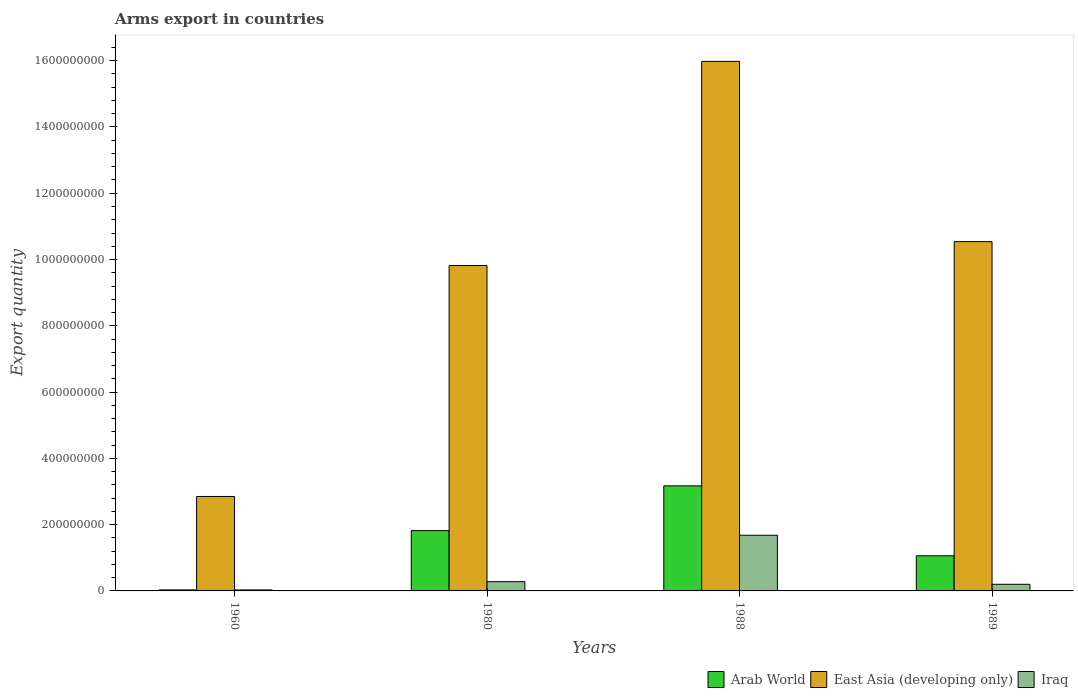How many different coloured bars are there?
Provide a succinct answer. 3. How many groups of bars are there?
Your response must be concise. 4. Are the number of bars per tick equal to the number of legend labels?
Your response must be concise. Yes. Are the number of bars on each tick of the X-axis equal?
Your answer should be very brief. Yes. How many bars are there on the 3rd tick from the left?
Give a very brief answer. 3. What is the label of the 1st group of bars from the left?
Offer a very short reply. 1960. In how many cases, is the number of bars for a given year not equal to the number of legend labels?
Ensure brevity in your answer.  0. What is the total arms export in Iraq in 1980?
Offer a terse response. 2.80e+07. Across all years, what is the maximum total arms export in Iraq?
Make the answer very short. 1.68e+08. In which year was the total arms export in East Asia (developing only) maximum?
Provide a succinct answer. 1988. What is the total total arms export in East Asia (developing only) in the graph?
Offer a very short reply. 3.92e+09. What is the difference between the total arms export in Iraq in 1960 and that in 1980?
Make the answer very short. -2.50e+07. What is the difference between the total arms export in Iraq in 1989 and the total arms export in East Asia (developing only) in 1980?
Offer a very short reply. -9.62e+08. What is the average total arms export in Arab World per year?
Your response must be concise. 1.52e+08. In the year 1988, what is the difference between the total arms export in East Asia (developing only) and total arms export in Arab World?
Your answer should be very brief. 1.28e+09. What is the ratio of the total arms export in Iraq in 1960 to that in 1988?
Your answer should be compact. 0.02. Is the total arms export in Arab World in 1988 less than that in 1989?
Make the answer very short. No. What is the difference between the highest and the second highest total arms export in East Asia (developing only)?
Provide a succinct answer. 5.44e+08. What is the difference between the highest and the lowest total arms export in Iraq?
Provide a short and direct response. 1.65e+08. In how many years, is the total arms export in East Asia (developing only) greater than the average total arms export in East Asia (developing only) taken over all years?
Offer a very short reply. 3. What does the 2nd bar from the left in 1980 represents?
Your answer should be very brief. East Asia (developing only). What does the 3rd bar from the right in 1988 represents?
Offer a very short reply. Arab World. Is it the case that in every year, the sum of the total arms export in Iraq and total arms export in Arab World is greater than the total arms export in East Asia (developing only)?
Provide a succinct answer. No. Are all the bars in the graph horizontal?
Your response must be concise. No. What is the difference between two consecutive major ticks on the Y-axis?
Your answer should be very brief. 2.00e+08. Does the graph contain any zero values?
Keep it short and to the point. No. Does the graph contain grids?
Provide a succinct answer. No. How many legend labels are there?
Your answer should be compact. 3. How are the legend labels stacked?
Your response must be concise. Horizontal. What is the title of the graph?
Ensure brevity in your answer.  Arms export in countries. Does "Colombia" appear as one of the legend labels in the graph?
Your answer should be compact. No. What is the label or title of the Y-axis?
Ensure brevity in your answer.  Export quantity. What is the Export quantity of East Asia (developing only) in 1960?
Provide a succinct answer. 2.85e+08. What is the Export quantity of Iraq in 1960?
Give a very brief answer. 3.00e+06. What is the Export quantity in Arab World in 1980?
Offer a terse response. 1.82e+08. What is the Export quantity of East Asia (developing only) in 1980?
Your answer should be very brief. 9.82e+08. What is the Export quantity in Iraq in 1980?
Ensure brevity in your answer.  2.80e+07. What is the Export quantity in Arab World in 1988?
Give a very brief answer. 3.17e+08. What is the Export quantity of East Asia (developing only) in 1988?
Offer a very short reply. 1.60e+09. What is the Export quantity in Iraq in 1988?
Your answer should be very brief. 1.68e+08. What is the Export quantity in Arab World in 1989?
Ensure brevity in your answer.  1.06e+08. What is the Export quantity of East Asia (developing only) in 1989?
Keep it short and to the point. 1.05e+09. What is the Export quantity of Iraq in 1989?
Your answer should be very brief. 2.00e+07. Across all years, what is the maximum Export quantity in Arab World?
Your answer should be compact. 3.17e+08. Across all years, what is the maximum Export quantity in East Asia (developing only)?
Ensure brevity in your answer.  1.60e+09. Across all years, what is the maximum Export quantity in Iraq?
Ensure brevity in your answer.  1.68e+08. Across all years, what is the minimum Export quantity of Arab World?
Ensure brevity in your answer.  3.00e+06. Across all years, what is the minimum Export quantity in East Asia (developing only)?
Give a very brief answer. 2.85e+08. What is the total Export quantity of Arab World in the graph?
Your answer should be compact. 6.08e+08. What is the total Export quantity of East Asia (developing only) in the graph?
Provide a short and direct response. 3.92e+09. What is the total Export quantity of Iraq in the graph?
Ensure brevity in your answer.  2.19e+08. What is the difference between the Export quantity of Arab World in 1960 and that in 1980?
Offer a very short reply. -1.79e+08. What is the difference between the Export quantity in East Asia (developing only) in 1960 and that in 1980?
Your answer should be very brief. -6.97e+08. What is the difference between the Export quantity of Iraq in 1960 and that in 1980?
Keep it short and to the point. -2.50e+07. What is the difference between the Export quantity in Arab World in 1960 and that in 1988?
Provide a short and direct response. -3.14e+08. What is the difference between the Export quantity of East Asia (developing only) in 1960 and that in 1988?
Offer a very short reply. -1.31e+09. What is the difference between the Export quantity in Iraq in 1960 and that in 1988?
Give a very brief answer. -1.65e+08. What is the difference between the Export quantity of Arab World in 1960 and that in 1989?
Your response must be concise. -1.03e+08. What is the difference between the Export quantity in East Asia (developing only) in 1960 and that in 1989?
Offer a very short reply. -7.69e+08. What is the difference between the Export quantity of Iraq in 1960 and that in 1989?
Make the answer very short. -1.70e+07. What is the difference between the Export quantity of Arab World in 1980 and that in 1988?
Give a very brief answer. -1.35e+08. What is the difference between the Export quantity of East Asia (developing only) in 1980 and that in 1988?
Offer a very short reply. -6.16e+08. What is the difference between the Export quantity in Iraq in 1980 and that in 1988?
Your answer should be very brief. -1.40e+08. What is the difference between the Export quantity of Arab World in 1980 and that in 1989?
Offer a terse response. 7.60e+07. What is the difference between the Export quantity of East Asia (developing only) in 1980 and that in 1989?
Offer a terse response. -7.20e+07. What is the difference between the Export quantity in Iraq in 1980 and that in 1989?
Ensure brevity in your answer.  8.00e+06. What is the difference between the Export quantity in Arab World in 1988 and that in 1989?
Keep it short and to the point. 2.11e+08. What is the difference between the Export quantity in East Asia (developing only) in 1988 and that in 1989?
Your response must be concise. 5.44e+08. What is the difference between the Export quantity of Iraq in 1988 and that in 1989?
Offer a very short reply. 1.48e+08. What is the difference between the Export quantity of Arab World in 1960 and the Export quantity of East Asia (developing only) in 1980?
Offer a very short reply. -9.79e+08. What is the difference between the Export quantity of Arab World in 1960 and the Export quantity of Iraq in 1980?
Your answer should be very brief. -2.50e+07. What is the difference between the Export quantity of East Asia (developing only) in 1960 and the Export quantity of Iraq in 1980?
Your answer should be very brief. 2.57e+08. What is the difference between the Export quantity in Arab World in 1960 and the Export quantity in East Asia (developing only) in 1988?
Your answer should be very brief. -1.60e+09. What is the difference between the Export quantity of Arab World in 1960 and the Export quantity of Iraq in 1988?
Keep it short and to the point. -1.65e+08. What is the difference between the Export quantity of East Asia (developing only) in 1960 and the Export quantity of Iraq in 1988?
Your response must be concise. 1.17e+08. What is the difference between the Export quantity of Arab World in 1960 and the Export quantity of East Asia (developing only) in 1989?
Offer a terse response. -1.05e+09. What is the difference between the Export quantity in Arab World in 1960 and the Export quantity in Iraq in 1989?
Keep it short and to the point. -1.70e+07. What is the difference between the Export quantity of East Asia (developing only) in 1960 and the Export quantity of Iraq in 1989?
Ensure brevity in your answer.  2.65e+08. What is the difference between the Export quantity in Arab World in 1980 and the Export quantity in East Asia (developing only) in 1988?
Your answer should be compact. -1.42e+09. What is the difference between the Export quantity in Arab World in 1980 and the Export quantity in Iraq in 1988?
Offer a terse response. 1.40e+07. What is the difference between the Export quantity of East Asia (developing only) in 1980 and the Export quantity of Iraq in 1988?
Ensure brevity in your answer.  8.14e+08. What is the difference between the Export quantity of Arab World in 1980 and the Export quantity of East Asia (developing only) in 1989?
Provide a succinct answer. -8.72e+08. What is the difference between the Export quantity of Arab World in 1980 and the Export quantity of Iraq in 1989?
Your response must be concise. 1.62e+08. What is the difference between the Export quantity in East Asia (developing only) in 1980 and the Export quantity in Iraq in 1989?
Your response must be concise. 9.62e+08. What is the difference between the Export quantity in Arab World in 1988 and the Export quantity in East Asia (developing only) in 1989?
Your answer should be very brief. -7.37e+08. What is the difference between the Export quantity of Arab World in 1988 and the Export quantity of Iraq in 1989?
Make the answer very short. 2.97e+08. What is the difference between the Export quantity in East Asia (developing only) in 1988 and the Export quantity in Iraq in 1989?
Your answer should be very brief. 1.58e+09. What is the average Export quantity of Arab World per year?
Keep it short and to the point. 1.52e+08. What is the average Export quantity of East Asia (developing only) per year?
Your response must be concise. 9.80e+08. What is the average Export quantity of Iraq per year?
Offer a terse response. 5.48e+07. In the year 1960, what is the difference between the Export quantity in Arab World and Export quantity in East Asia (developing only)?
Your answer should be very brief. -2.82e+08. In the year 1960, what is the difference between the Export quantity in Arab World and Export quantity in Iraq?
Your response must be concise. 0. In the year 1960, what is the difference between the Export quantity in East Asia (developing only) and Export quantity in Iraq?
Your answer should be very brief. 2.82e+08. In the year 1980, what is the difference between the Export quantity in Arab World and Export quantity in East Asia (developing only)?
Keep it short and to the point. -8.00e+08. In the year 1980, what is the difference between the Export quantity of Arab World and Export quantity of Iraq?
Make the answer very short. 1.54e+08. In the year 1980, what is the difference between the Export quantity in East Asia (developing only) and Export quantity in Iraq?
Give a very brief answer. 9.54e+08. In the year 1988, what is the difference between the Export quantity of Arab World and Export quantity of East Asia (developing only)?
Your answer should be compact. -1.28e+09. In the year 1988, what is the difference between the Export quantity in Arab World and Export quantity in Iraq?
Keep it short and to the point. 1.49e+08. In the year 1988, what is the difference between the Export quantity of East Asia (developing only) and Export quantity of Iraq?
Provide a succinct answer. 1.43e+09. In the year 1989, what is the difference between the Export quantity of Arab World and Export quantity of East Asia (developing only)?
Offer a very short reply. -9.48e+08. In the year 1989, what is the difference between the Export quantity in Arab World and Export quantity in Iraq?
Provide a succinct answer. 8.60e+07. In the year 1989, what is the difference between the Export quantity in East Asia (developing only) and Export quantity in Iraq?
Your answer should be very brief. 1.03e+09. What is the ratio of the Export quantity of Arab World in 1960 to that in 1980?
Give a very brief answer. 0.02. What is the ratio of the Export quantity in East Asia (developing only) in 1960 to that in 1980?
Your response must be concise. 0.29. What is the ratio of the Export quantity of Iraq in 1960 to that in 1980?
Make the answer very short. 0.11. What is the ratio of the Export quantity of Arab World in 1960 to that in 1988?
Your answer should be compact. 0.01. What is the ratio of the Export quantity in East Asia (developing only) in 1960 to that in 1988?
Offer a very short reply. 0.18. What is the ratio of the Export quantity in Iraq in 1960 to that in 1988?
Offer a terse response. 0.02. What is the ratio of the Export quantity in Arab World in 1960 to that in 1989?
Your answer should be very brief. 0.03. What is the ratio of the Export quantity of East Asia (developing only) in 1960 to that in 1989?
Provide a succinct answer. 0.27. What is the ratio of the Export quantity of Iraq in 1960 to that in 1989?
Your answer should be very brief. 0.15. What is the ratio of the Export quantity in Arab World in 1980 to that in 1988?
Provide a short and direct response. 0.57. What is the ratio of the Export quantity in East Asia (developing only) in 1980 to that in 1988?
Your answer should be very brief. 0.61. What is the ratio of the Export quantity in Arab World in 1980 to that in 1989?
Ensure brevity in your answer.  1.72. What is the ratio of the Export quantity in East Asia (developing only) in 1980 to that in 1989?
Offer a terse response. 0.93. What is the ratio of the Export quantity of Iraq in 1980 to that in 1989?
Ensure brevity in your answer.  1.4. What is the ratio of the Export quantity in Arab World in 1988 to that in 1989?
Offer a very short reply. 2.99. What is the ratio of the Export quantity of East Asia (developing only) in 1988 to that in 1989?
Provide a short and direct response. 1.52. What is the ratio of the Export quantity in Iraq in 1988 to that in 1989?
Your response must be concise. 8.4. What is the difference between the highest and the second highest Export quantity of Arab World?
Your response must be concise. 1.35e+08. What is the difference between the highest and the second highest Export quantity in East Asia (developing only)?
Your answer should be very brief. 5.44e+08. What is the difference between the highest and the second highest Export quantity of Iraq?
Your answer should be compact. 1.40e+08. What is the difference between the highest and the lowest Export quantity in Arab World?
Your answer should be very brief. 3.14e+08. What is the difference between the highest and the lowest Export quantity of East Asia (developing only)?
Your answer should be compact. 1.31e+09. What is the difference between the highest and the lowest Export quantity in Iraq?
Make the answer very short. 1.65e+08. 